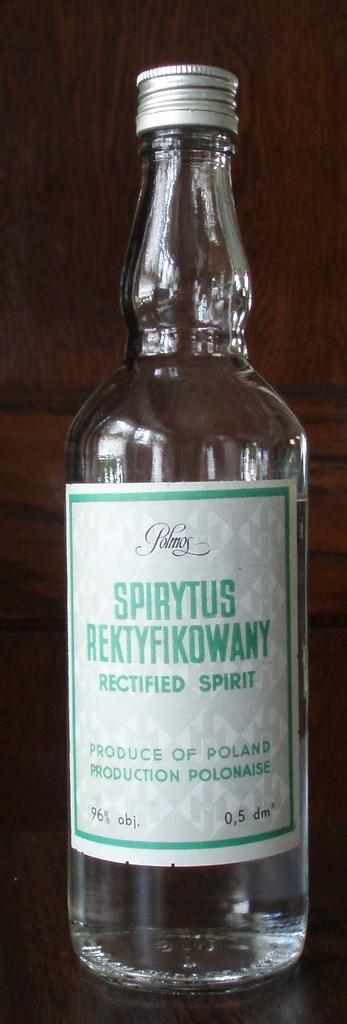<image>
Describe the image concisely. a bottle of liquid with Spirytus written on it 